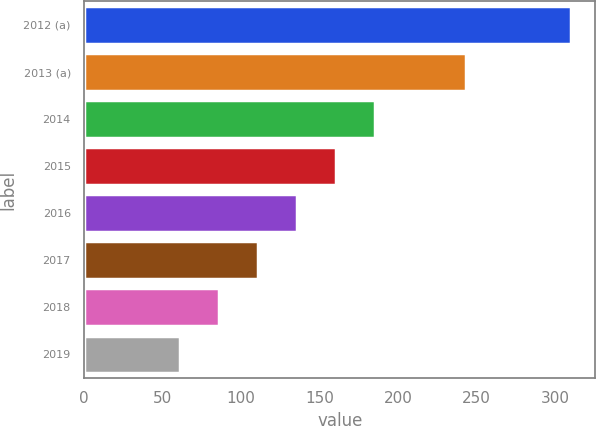Convert chart. <chart><loc_0><loc_0><loc_500><loc_500><bar_chart><fcel>2012 (a)<fcel>2013 (a)<fcel>2014<fcel>2015<fcel>2016<fcel>2017<fcel>2018<fcel>2019<nl><fcel>310<fcel>243<fcel>185.5<fcel>160.6<fcel>135.7<fcel>110.8<fcel>85.9<fcel>61<nl></chart> 